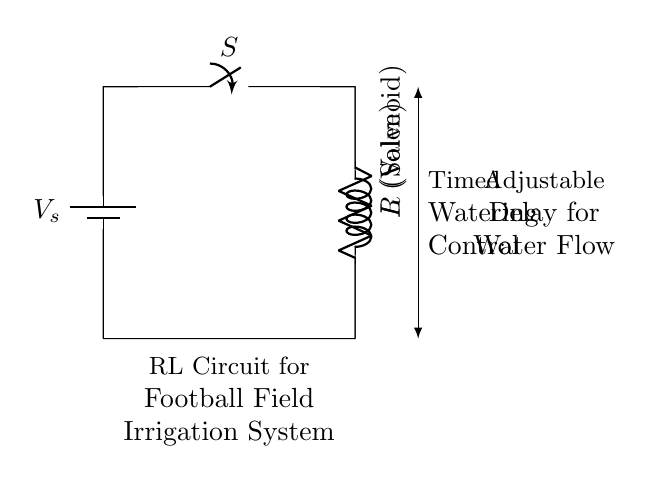What are the two main components of this circuit? The circuit consists of a resistor (R) and an inductor (L), as clearly labeled in the diagram.
Answer: Resistor and Inductor What does the 'S' in the circuit represent? The 'S' represents a switch, which is a control element that can open or close the circuit to start or stop the flow of current.
Answer: Switch What is the purpose of the inductor in this irrigation system? The inductor (L) in this context acts as a valve, controlling the flow of water by storing energy when the current flows, then releasing it.
Answer: Valve What is the function of the resistor in the circuit? The resistor (R) limits the amount of current flowing through the circuit, which can be crucial for protecting the irrigation components from excessive current.
Answer: Current Limiter How does the adjustable delay feature work in this circuit? The adjustable delay works by utilizing the inductor's property of opposing changes in current. When the switch is turned on, the inductor gradually allows current to increase, providing a timed delay before the valve opens fully.
Answer: Timed Delay What happens when the switch is closed? When the switch is closed, the circuit completes, allowing current to flow through the resistor and inductor, activating the irrigation system.
Answer: Activates System What type of circuit is this? This circuit is classified as an RL circuit, which is characterized by having a resistor and inductor in series or parallel.
Answer: RL Circuit 